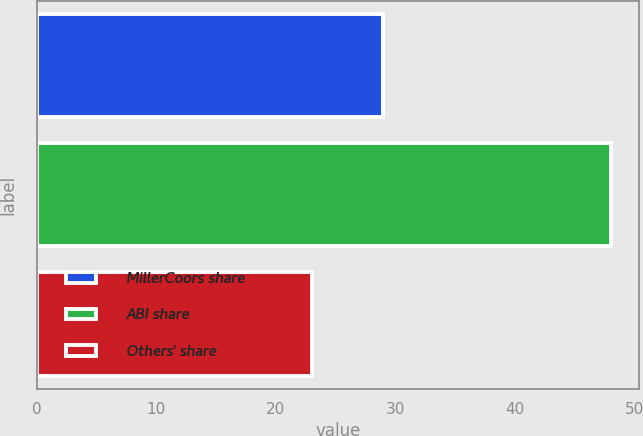<chart> <loc_0><loc_0><loc_500><loc_500><bar_chart><fcel>MillerCoors share<fcel>ABI share<fcel>Others' share<nl><fcel>29<fcel>48<fcel>23<nl></chart> 